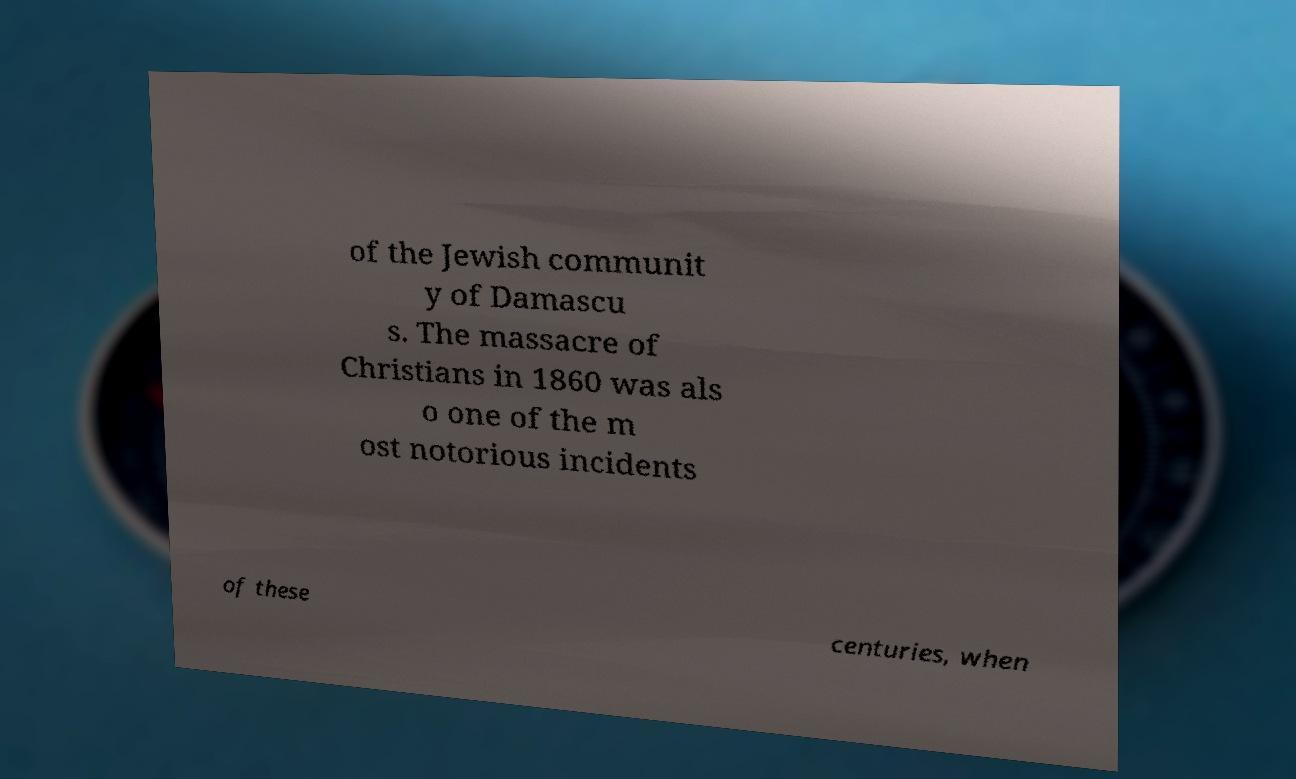There's text embedded in this image that I need extracted. Can you transcribe it verbatim? of the Jewish communit y of Damascu s. The massacre of Christians in 1860 was als o one of the m ost notorious incidents of these centuries, when 